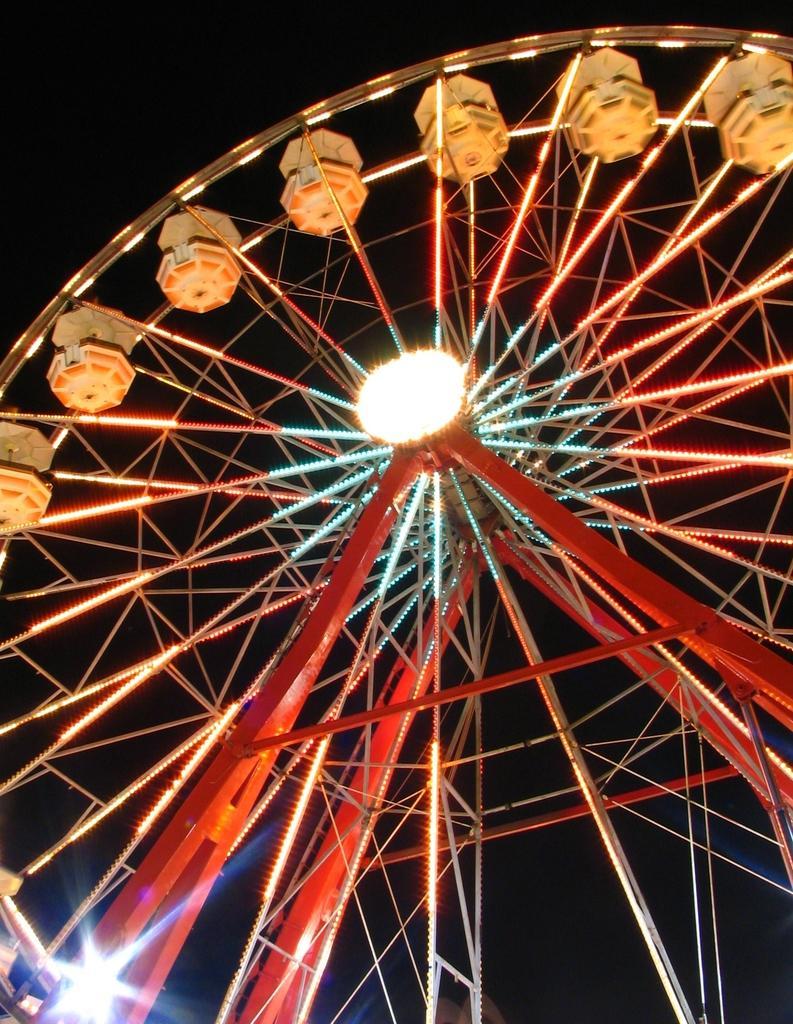Please provide a concise description of this image. This image consist of an amusement ride. 